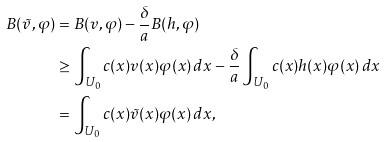Convert formula to latex. <formula><loc_0><loc_0><loc_500><loc_500>B ( \tilde { v } , \varphi ) & = B ( v , \varphi ) - \frac { \delta } { a } B ( h , \varphi ) \\ & \geq \int _ { U _ { 0 } } c ( x ) v ( x ) \varphi ( x ) \, d x - \frac { \delta } { a } \int _ { U _ { 0 } } c ( x ) h ( x ) \varphi ( x ) \, d x \\ & = \int _ { U _ { 0 } } c ( x ) \tilde { v } ( x ) \varphi ( x ) \, d x ,</formula> 